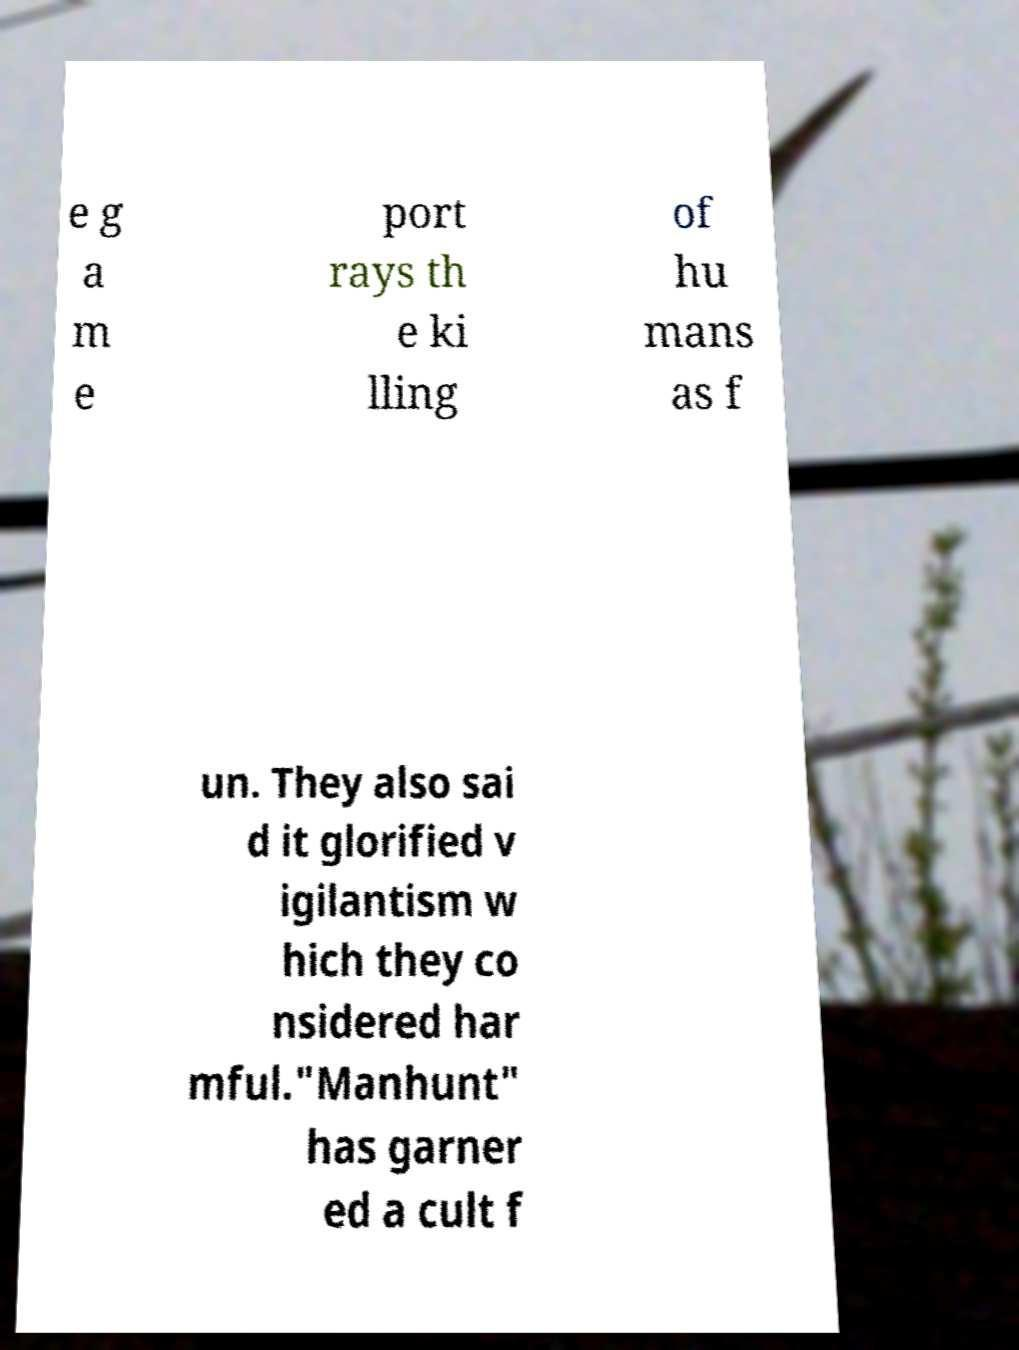For documentation purposes, I need the text within this image transcribed. Could you provide that? e g a m e port rays th e ki lling of hu mans as f un. They also sai d it glorified v igilantism w hich they co nsidered har mful."Manhunt" has garner ed a cult f 